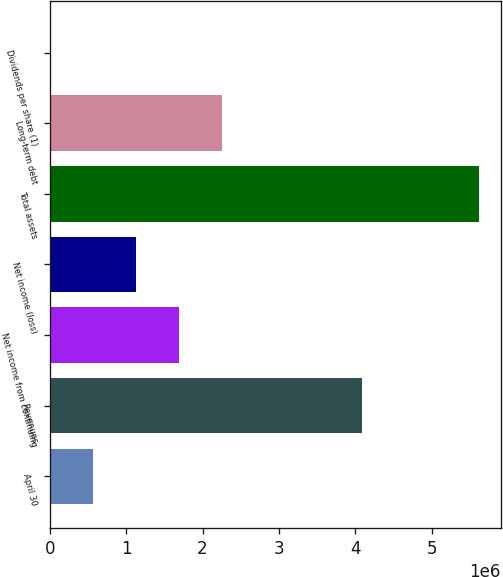Convert chart to OTSL. <chart><loc_0><loc_0><loc_500><loc_500><bar_chart><fcel>April 30<fcel>Revenues<fcel>Net income from continuing<fcel>Net income (loss)<fcel>Total assets<fcel>Long-term debt<fcel>Dividends per share (1)<nl><fcel>562343<fcel>4.08663e+06<fcel>1.68703e+06<fcel>1.12469e+06<fcel>5.62342e+06<fcel>2.24937e+06<fcel>0.56<nl></chart> 